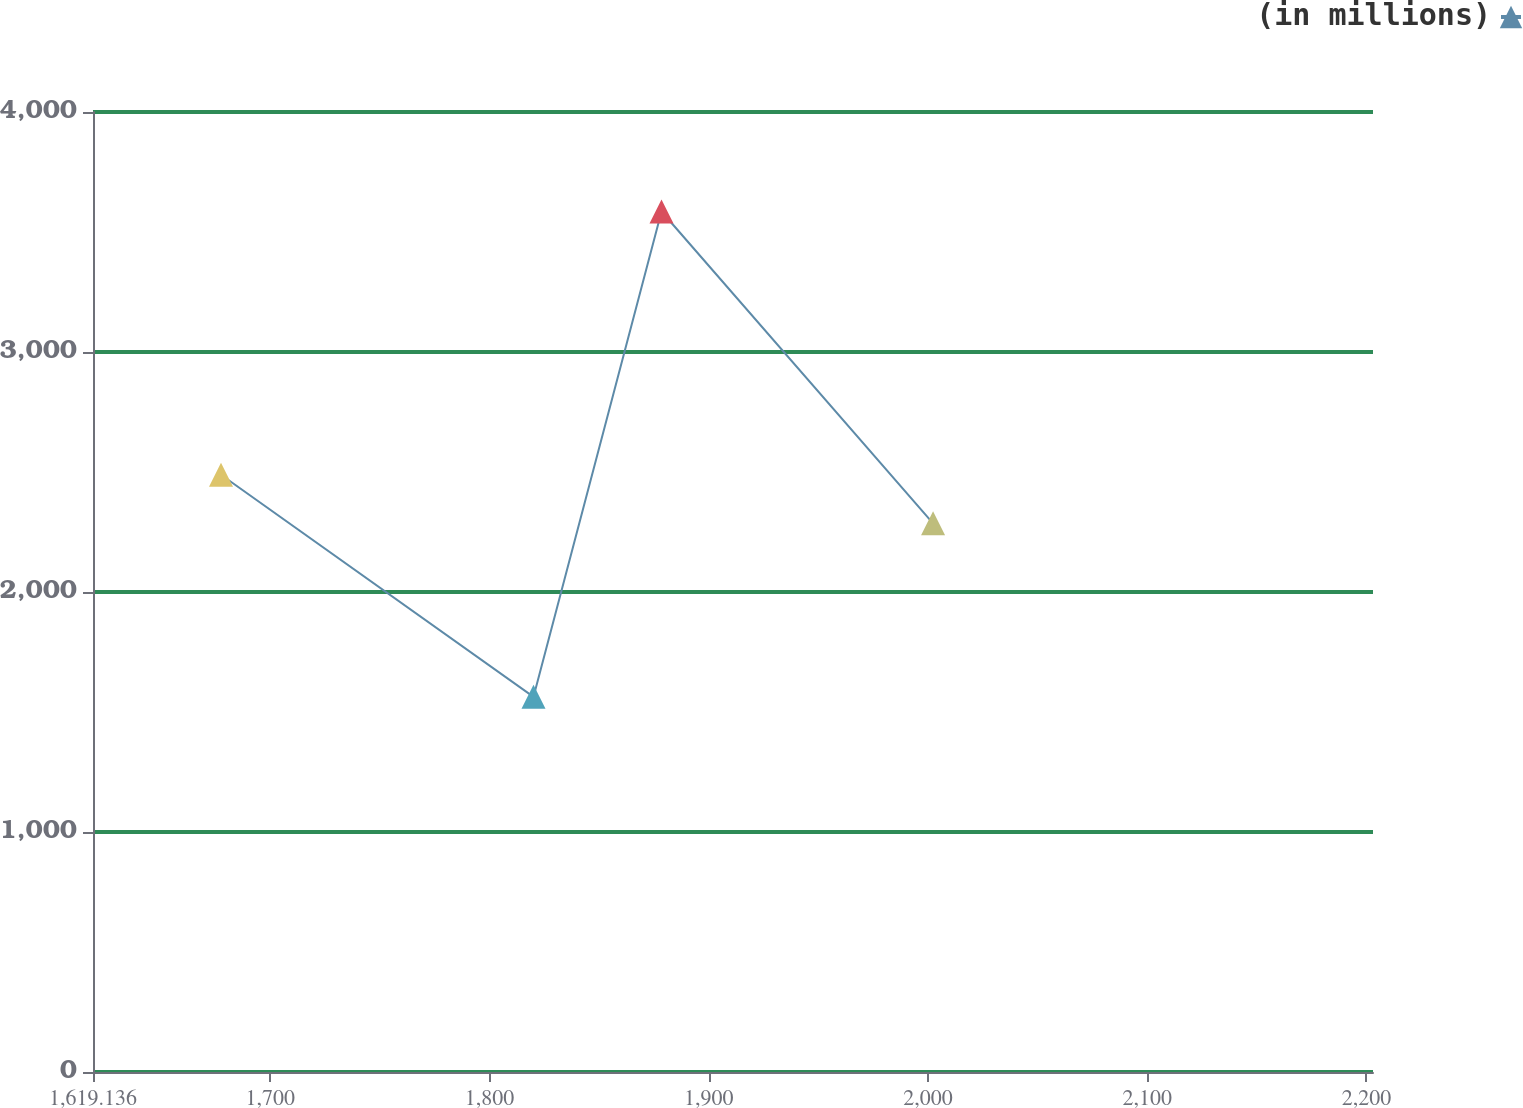Convert chart to OTSL. <chart><loc_0><loc_0><loc_500><loc_500><line_chart><ecel><fcel>(in millions)<nl><fcel>1677.52<fcel>2488.53<nl><fcel>1820.07<fcel>1563.12<nl><fcel>1878.45<fcel>3585.48<nl><fcel>2002.32<fcel>2286.29<nl><fcel>2261.36<fcel>2926.15<nl></chart> 